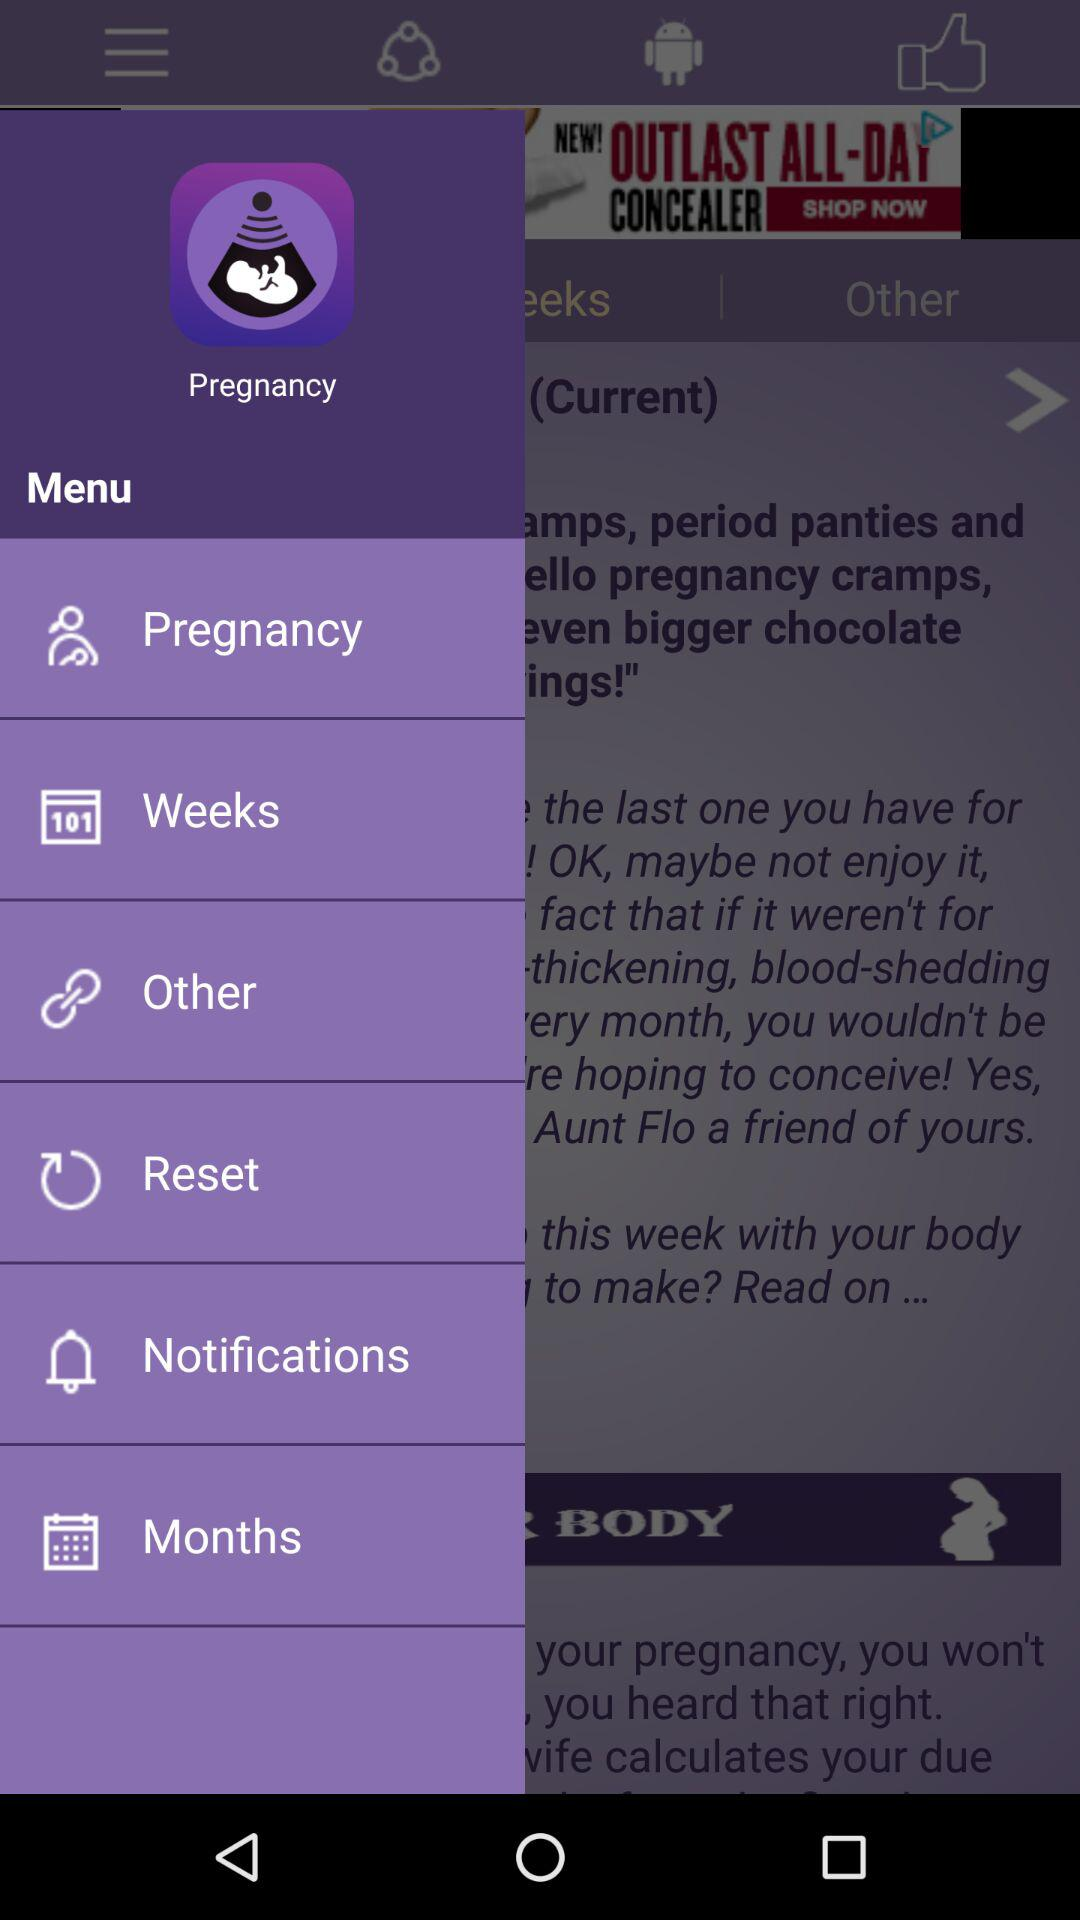What is the name of the application? The name of the application is "Pregnancy". 